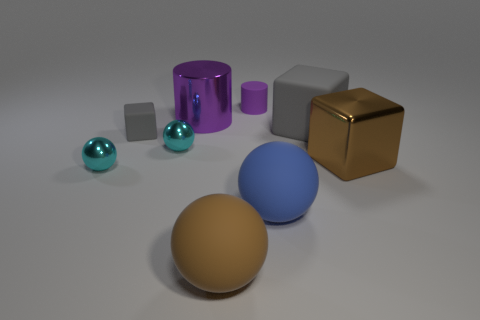Subtract 1 blocks. How many blocks are left? 2 Add 1 big blue cubes. How many objects exist? 10 Subtract all gray matte blocks. How many blocks are left? 1 Subtract all blocks. How many objects are left? 6 Subtract all green balls. How many brown blocks are left? 1 Subtract all tiny cyan things. Subtract all gray rubber blocks. How many objects are left? 5 Add 7 tiny purple cylinders. How many tiny purple cylinders are left? 8 Add 1 tiny gray blocks. How many tiny gray blocks exist? 2 Subtract all blue balls. How many balls are left? 3 Subtract 0 brown cylinders. How many objects are left? 9 